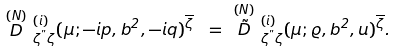<formula> <loc_0><loc_0><loc_500><loc_500>\stackrel { ( N ) } { D } \, ^ { ( i ) } _ { \zeta ^ { " } \zeta } ( \mu ; - i p , b ^ { 2 } , - i q ) ^ { \overline { \zeta } } \ = \ \stackrel { ( N ) } { \tilde { D } } \, ^ { ( i ) } _ { \zeta ^ { " } \zeta } ( \mu ; \varrho , b ^ { 2 } , u ) ^ { \overline { \zeta } } .</formula> 